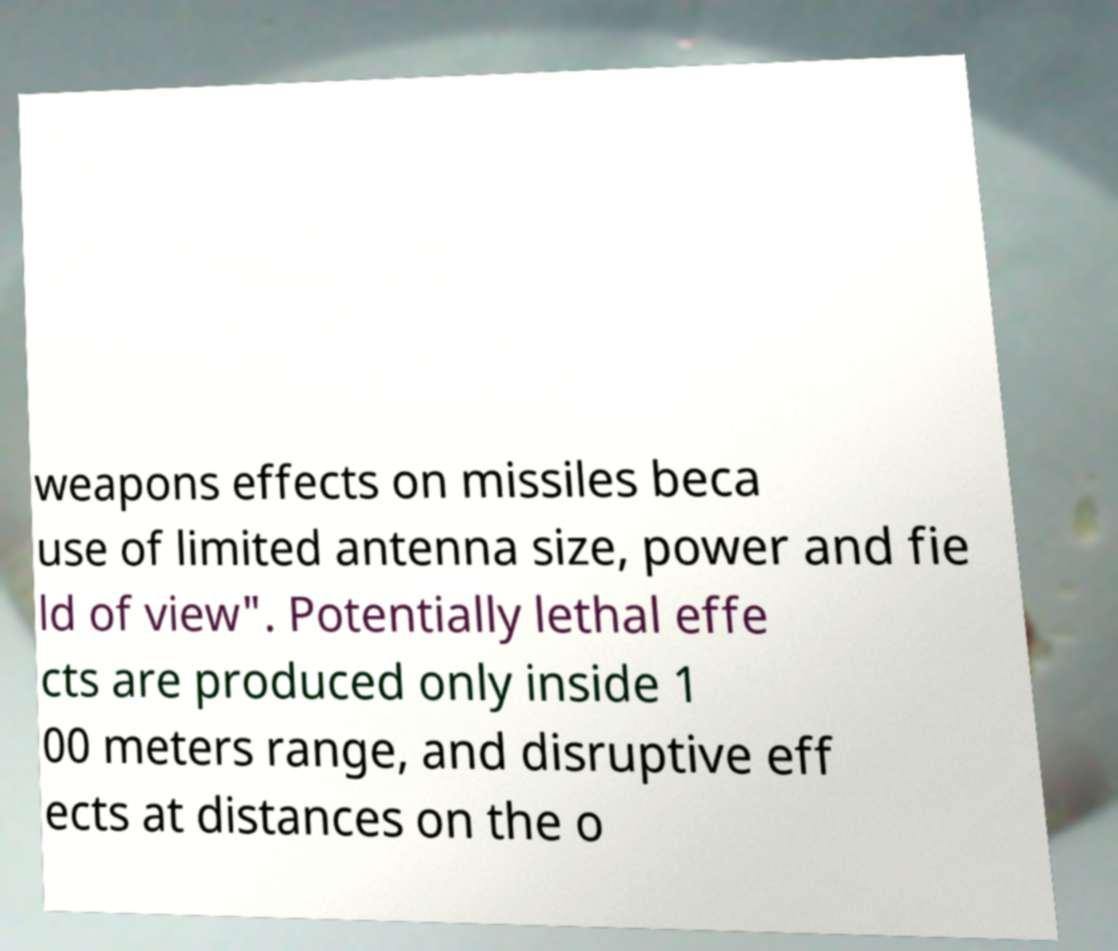For documentation purposes, I need the text within this image transcribed. Could you provide that? weapons effects on missiles beca use of limited antenna size, power and fie ld of view". Potentially lethal effe cts are produced only inside 1 00 meters range, and disruptive eff ects at distances on the o 